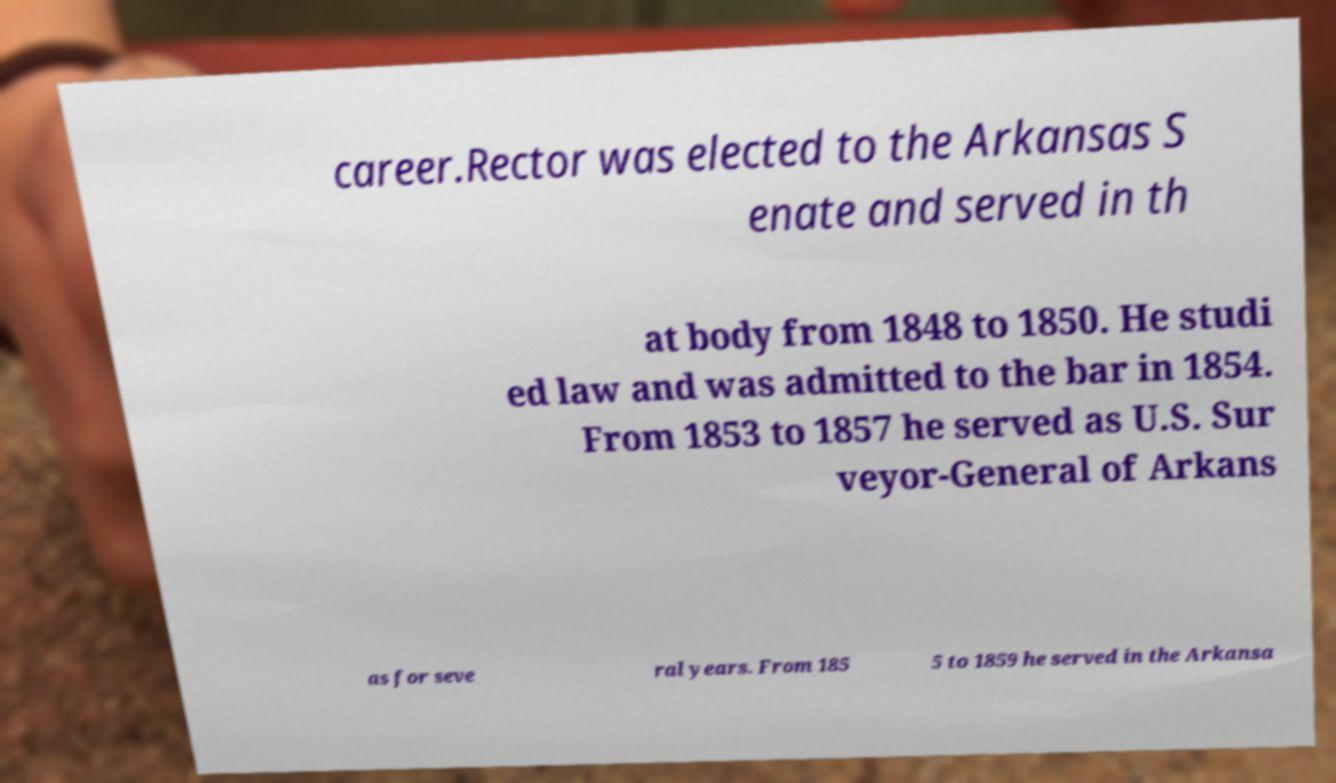I need the written content from this picture converted into text. Can you do that? career.Rector was elected to the Arkansas S enate and served in th at body from 1848 to 1850. He studi ed law and was admitted to the bar in 1854. From 1853 to 1857 he served as U.S. Sur veyor-General of Arkans as for seve ral years. From 185 5 to 1859 he served in the Arkansa 